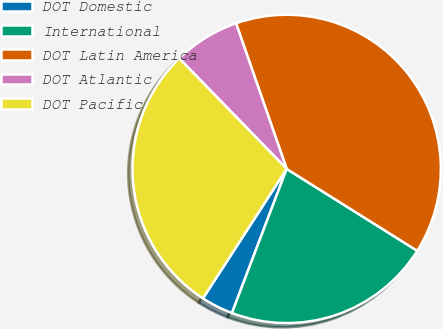Convert chart. <chart><loc_0><loc_0><loc_500><loc_500><pie_chart><fcel>DOT Domestic<fcel>International<fcel>DOT Latin America<fcel>DOT Atlantic<fcel>DOT Pacific<nl><fcel>3.36%<fcel>21.86%<fcel>39.24%<fcel>6.95%<fcel>28.59%<nl></chart> 